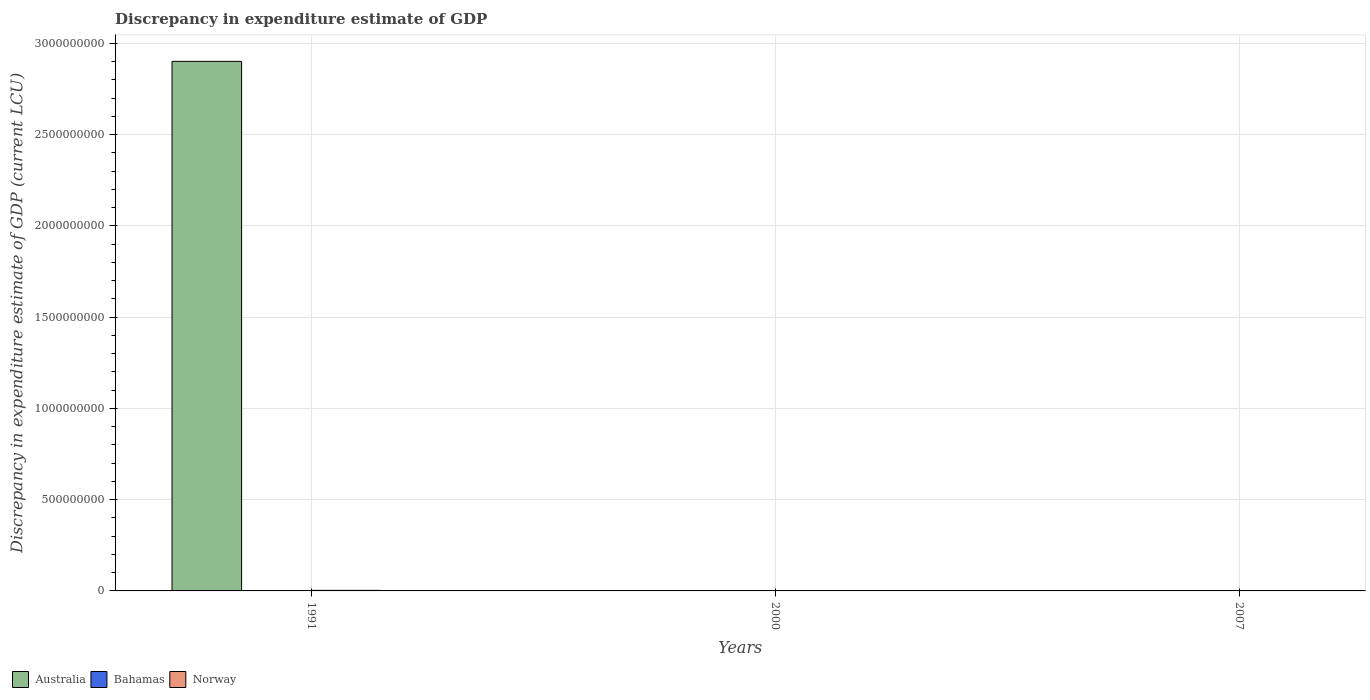How many different coloured bars are there?
Provide a succinct answer. 3. Are the number of bars per tick equal to the number of legend labels?
Your answer should be very brief. No. Are the number of bars on each tick of the X-axis equal?
Your response must be concise. No. In how many cases, is the number of bars for a given year not equal to the number of legend labels?
Make the answer very short. 3. What is the discrepancy in expenditure estimate of GDP in Norway in 1991?
Your answer should be very brief. 3.00e+06. Across all years, what is the maximum discrepancy in expenditure estimate of GDP in Bahamas?
Give a very brief answer. 2000. Across all years, what is the minimum discrepancy in expenditure estimate of GDP in Australia?
Keep it short and to the point. 0. In which year was the discrepancy in expenditure estimate of GDP in Australia maximum?
Give a very brief answer. 1991. What is the total discrepancy in expenditure estimate of GDP in Australia in the graph?
Offer a terse response. 2.90e+09. What is the difference between the discrepancy in expenditure estimate of GDP in Australia in 1991 and that in 2007?
Offer a very short reply. 2.90e+09. What is the difference between the discrepancy in expenditure estimate of GDP in Norway in 2007 and the discrepancy in expenditure estimate of GDP in Australia in 1991?
Provide a succinct answer. -2.90e+09. What is the average discrepancy in expenditure estimate of GDP in Australia per year?
Your answer should be compact. 9.67e+08. In the year 2000, what is the difference between the discrepancy in expenditure estimate of GDP in Norway and discrepancy in expenditure estimate of GDP in Bahamas?
Ensure brevity in your answer.  9.98e+05. What is the difference between the highest and the lowest discrepancy in expenditure estimate of GDP in Bahamas?
Provide a succinct answer. 2000. In how many years, is the discrepancy in expenditure estimate of GDP in Bahamas greater than the average discrepancy in expenditure estimate of GDP in Bahamas taken over all years?
Offer a terse response. 1. How many bars are there?
Provide a short and direct response. 5. How many years are there in the graph?
Give a very brief answer. 3. Are the values on the major ticks of Y-axis written in scientific E-notation?
Give a very brief answer. No. Does the graph contain any zero values?
Your answer should be very brief. Yes. Does the graph contain grids?
Your answer should be compact. Yes. How are the legend labels stacked?
Your answer should be compact. Horizontal. What is the title of the graph?
Make the answer very short. Discrepancy in expenditure estimate of GDP. Does "Vanuatu" appear as one of the legend labels in the graph?
Offer a terse response. No. What is the label or title of the X-axis?
Provide a short and direct response. Years. What is the label or title of the Y-axis?
Give a very brief answer. Discrepancy in expenditure estimate of GDP (current LCU). What is the Discrepancy in expenditure estimate of GDP (current LCU) of Australia in 1991?
Your answer should be compact. 2.90e+09. What is the Discrepancy in expenditure estimate of GDP (current LCU) of Bahamas in 2000?
Offer a very short reply. 2000. What is the Discrepancy in expenditure estimate of GDP (current LCU) in Bahamas in 2007?
Ensure brevity in your answer.  0. Across all years, what is the maximum Discrepancy in expenditure estimate of GDP (current LCU) in Australia?
Provide a succinct answer. 2.90e+09. Across all years, what is the maximum Discrepancy in expenditure estimate of GDP (current LCU) of Bahamas?
Ensure brevity in your answer.  2000. Across all years, what is the maximum Discrepancy in expenditure estimate of GDP (current LCU) in Norway?
Your response must be concise. 3.00e+06. Across all years, what is the minimum Discrepancy in expenditure estimate of GDP (current LCU) of Australia?
Your answer should be very brief. 0. Across all years, what is the minimum Discrepancy in expenditure estimate of GDP (current LCU) in Bahamas?
Keep it short and to the point. 0. Across all years, what is the minimum Discrepancy in expenditure estimate of GDP (current LCU) of Norway?
Offer a terse response. 0. What is the total Discrepancy in expenditure estimate of GDP (current LCU) in Australia in the graph?
Your response must be concise. 2.90e+09. What is the difference between the Discrepancy in expenditure estimate of GDP (current LCU) of Australia in 1991 and that in 2007?
Your answer should be compact. 2.90e+09. What is the difference between the Discrepancy in expenditure estimate of GDP (current LCU) of Australia in 1991 and the Discrepancy in expenditure estimate of GDP (current LCU) of Bahamas in 2000?
Ensure brevity in your answer.  2.90e+09. What is the difference between the Discrepancy in expenditure estimate of GDP (current LCU) in Australia in 1991 and the Discrepancy in expenditure estimate of GDP (current LCU) in Norway in 2000?
Give a very brief answer. 2.90e+09. What is the average Discrepancy in expenditure estimate of GDP (current LCU) of Australia per year?
Make the answer very short. 9.67e+08. What is the average Discrepancy in expenditure estimate of GDP (current LCU) in Bahamas per year?
Provide a short and direct response. 666.67. What is the average Discrepancy in expenditure estimate of GDP (current LCU) of Norway per year?
Your response must be concise. 1.33e+06. In the year 1991, what is the difference between the Discrepancy in expenditure estimate of GDP (current LCU) of Australia and Discrepancy in expenditure estimate of GDP (current LCU) of Norway?
Your answer should be very brief. 2.90e+09. In the year 2000, what is the difference between the Discrepancy in expenditure estimate of GDP (current LCU) in Bahamas and Discrepancy in expenditure estimate of GDP (current LCU) in Norway?
Your answer should be very brief. -9.98e+05. What is the ratio of the Discrepancy in expenditure estimate of GDP (current LCU) of Australia in 1991 to that in 2007?
Keep it short and to the point. 2901. What is the difference between the highest and the lowest Discrepancy in expenditure estimate of GDP (current LCU) in Australia?
Keep it short and to the point. 2.90e+09. 